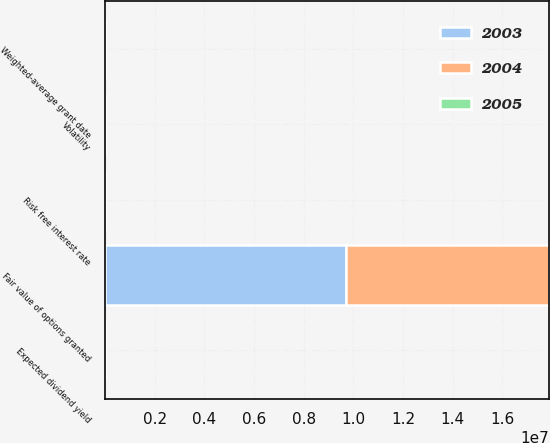Convert chart to OTSL. <chart><loc_0><loc_0><loc_500><loc_500><stacked_bar_chart><ecel><fcel>Expected dividend yield<fcel>Volatility<fcel>Risk free interest rate<fcel>Fair value of options granted<fcel>Weighted-average grant date<nl><fcel>2003<fcel>0<fcel>38.44<fcel>3.74<fcel>9.701e+06<fcel>17.16<nl><fcel>2004<fcel>0<fcel>50<fcel>3.25<fcel>8.178e+06<fcel>24.56<nl><fcel>2005<fcel>0<fcel>53<fcel>3.29<fcel>15.58<fcel>14<nl></chart> 